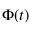Convert formula to latex. <formula><loc_0><loc_0><loc_500><loc_500>\Phi ( t )</formula> 